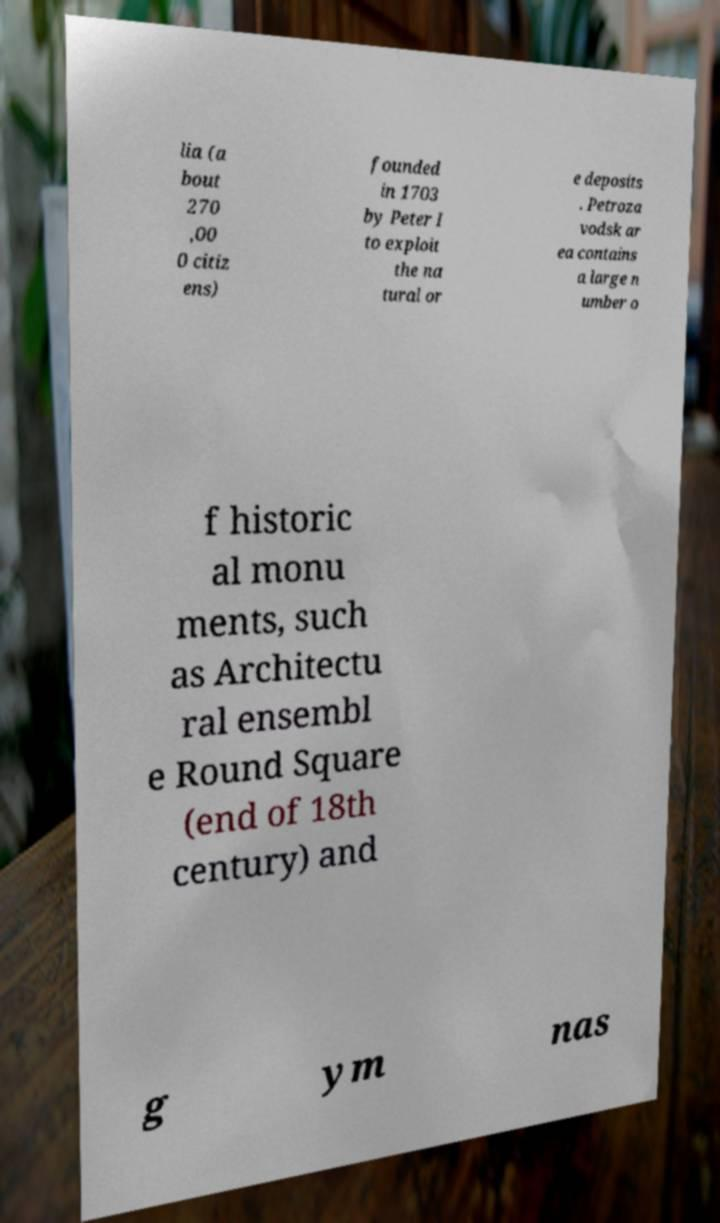Please identify and transcribe the text found in this image. lia (a bout 270 ,00 0 citiz ens) founded in 1703 by Peter I to exploit the na tural or e deposits . Petroza vodsk ar ea contains a large n umber o f historic al monu ments, such as Architectu ral ensembl e Round Square (end of 18th century) and g ym nas 